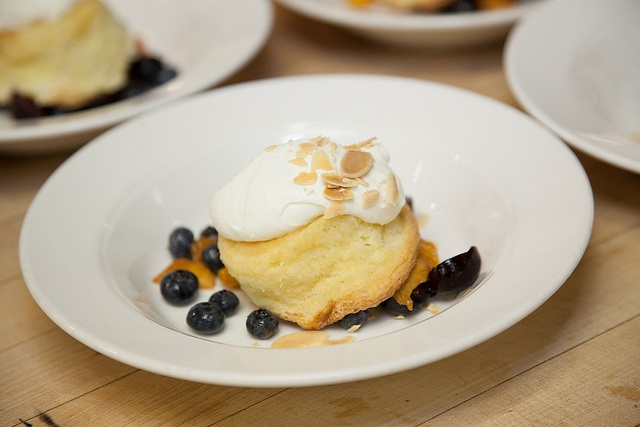Describe the objects in this image and their specific colors. I can see dining table in lightgray, tan, maroon, and darkgray tones, bowl in darkgray, lightgray, and tan tones, cake in darkgray, ivory, tan, and khaki tones, bowl in darkgray, tan, and lightgray tones, and bowl in darkgray and lightgray tones in this image. 